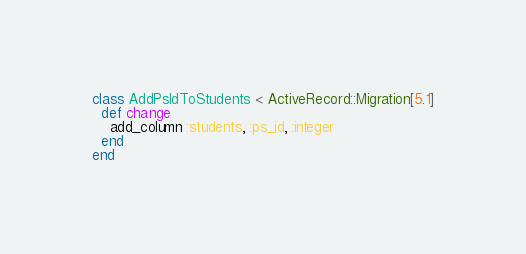<code> <loc_0><loc_0><loc_500><loc_500><_Ruby_>class AddPsIdToStudents < ActiveRecord::Migration[5.1]
  def change
  	add_column :students, :ps_id, :integer
  end
end
</code> 